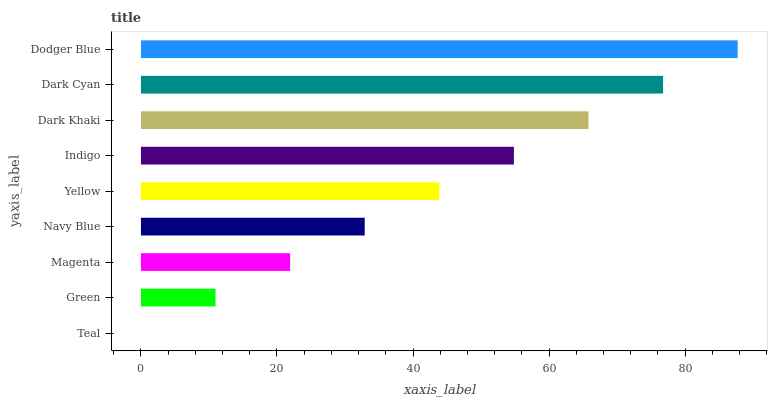Is Teal the minimum?
Answer yes or no. Yes. Is Dodger Blue the maximum?
Answer yes or no. Yes. Is Green the minimum?
Answer yes or no. No. Is Green the maximum?
Answer yes or no. No. Is Green greater than Teal?
Answer yes or no. Yes. Is Teal less than Green?
Answer yes or no. Yes. Is Teal greater than Green?
Answer yes or no. No. Is Green less than Teal?
Answer yes or no. No. Is Yellow the high median?
Answer yes or no. Yes. Is Yellow the low median?
Answer yes or no. Yes. Is Indigo the high median?
Answer yes or no. No. Is Dark Cyan the low median?
Answer yes or no. No. 